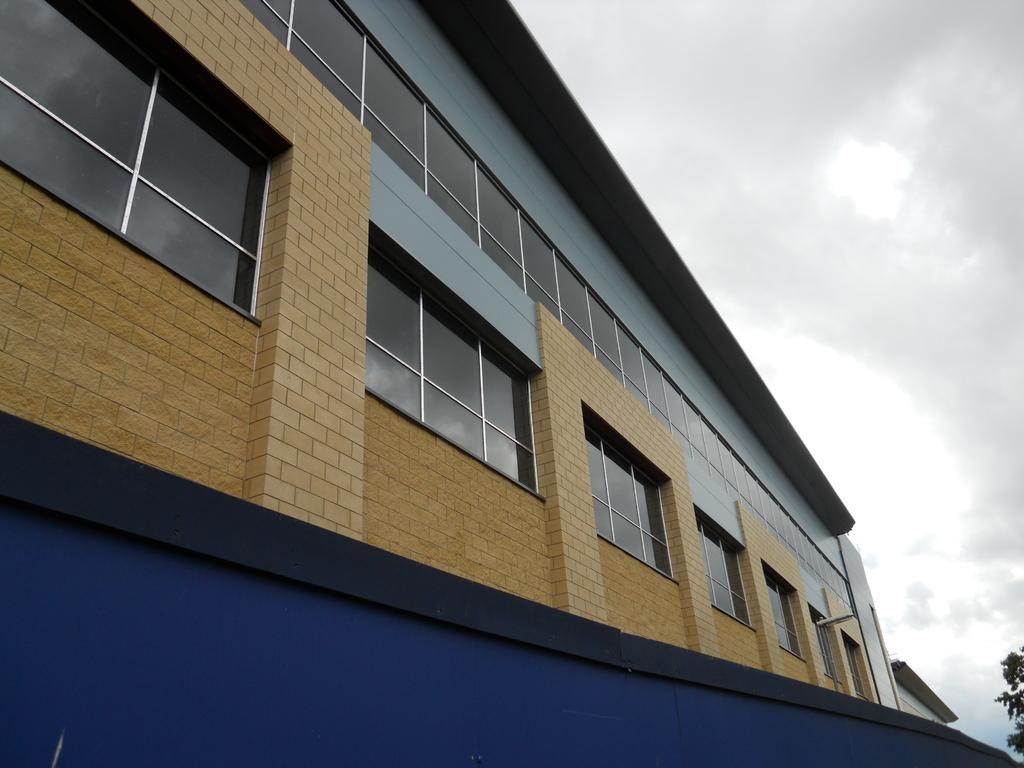What type of building is visible in the image? There is a building with glass in the image. What can be seen on the right side of the image? There is a tree on the right side of the image. What is visible in the sky in the image? Clouds are visible in the sky. How many boys are using a rake in the image? There are no boys or rakes present in the image. 